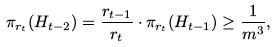<formula> <loc_0><loc_0><loc_500><loc_500>\pi _ { r _ { t } } ( H _ { t - 2 } ) = \frac { r _ { t - 1 } } { r _ { t } } \cdot \pi _ { r _ { t } } ( H _ { t - 1 } ) \geq \frac { 1 } { m ^ { 3 } } ,</formula> 